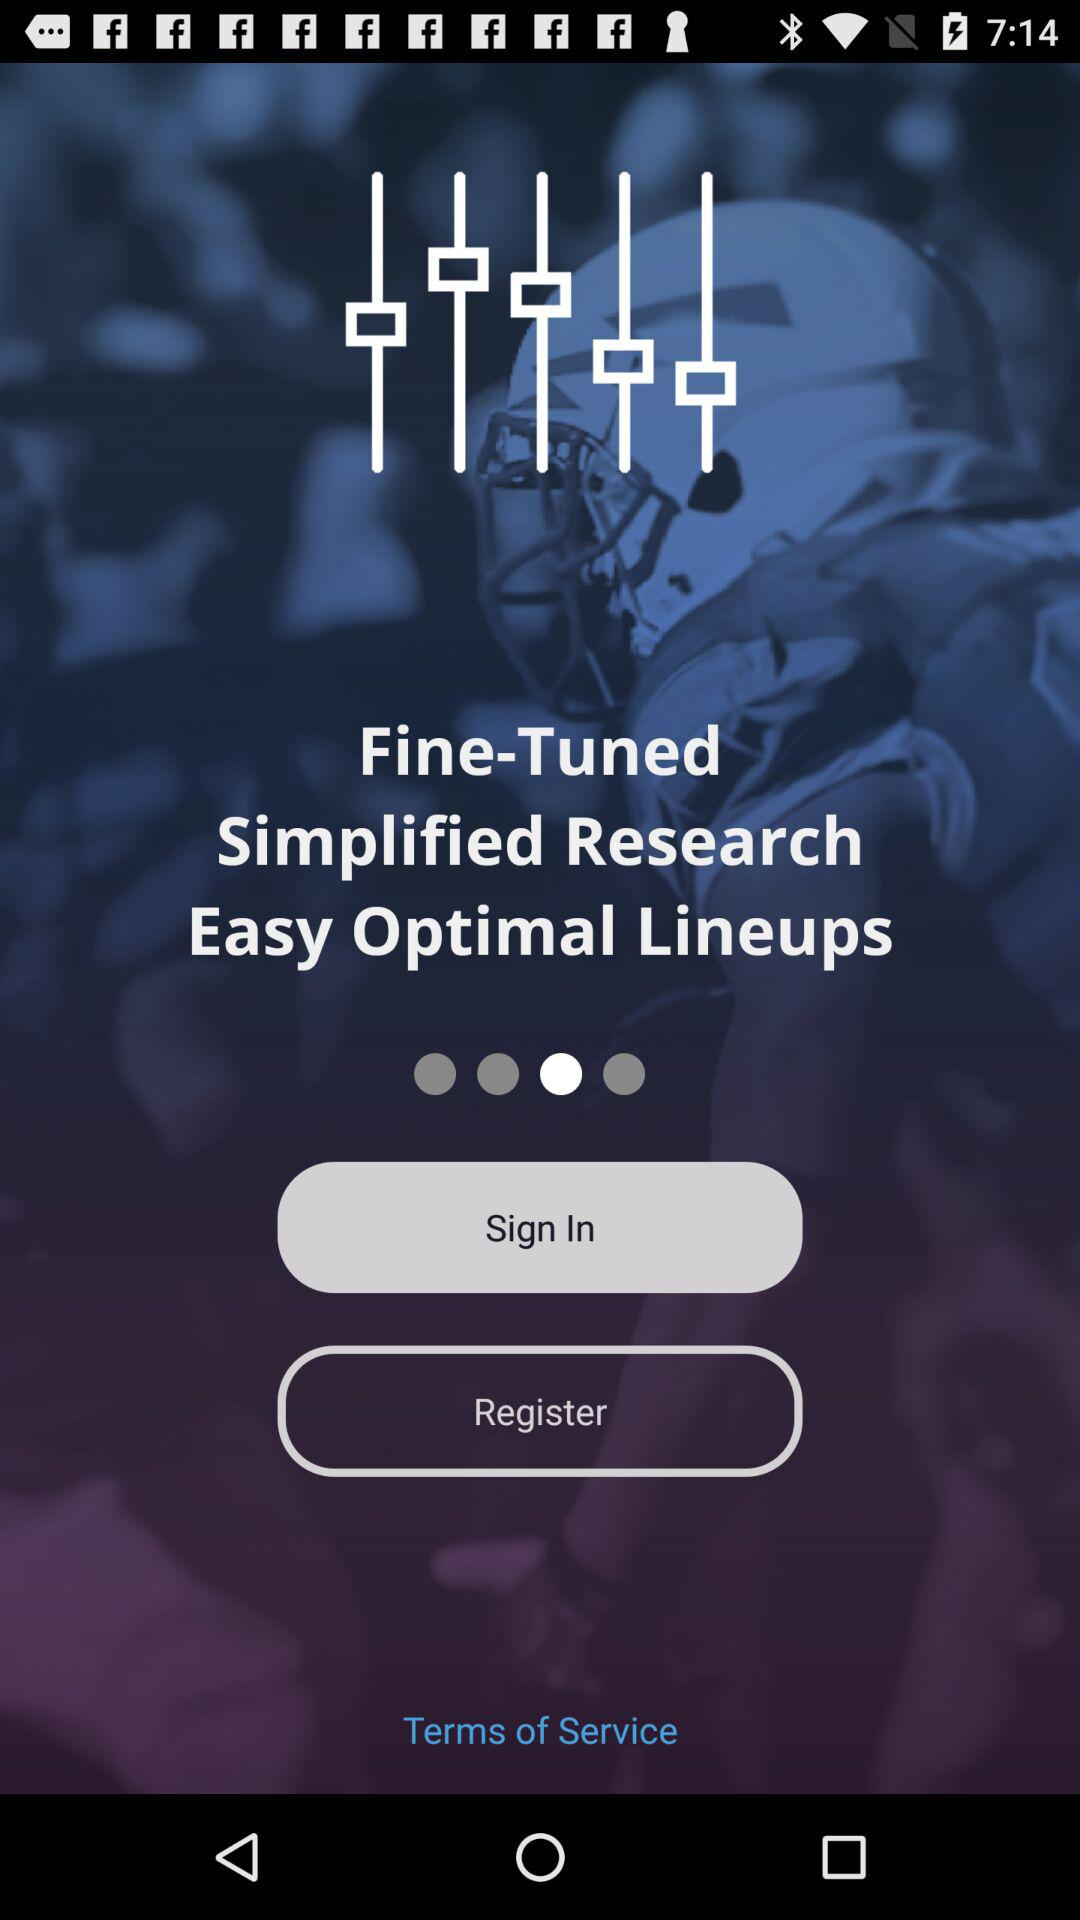What is the application name?
When the provided information is insufficient, respond with <no answer>. <no answer> 